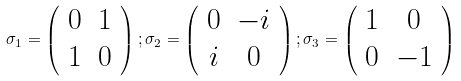Convert formula to latex. <formula><loc_0><loc_0><loc_500><loc_500>\sigma _ { 1 } = \left ( \begin{array} { c c } 0 & 1 \\ 1 & 0 \end{array} \right ) ; \sigma _ { 2 } = \left ( \begin{array} { c c } 0 & - i \\ i & 0 \end{array} \right ) ; \sigma _ { 3 } = \left ( \begin{array} { c c } 1 & 0 \\ 0 & - 1 \end{array} \right )</formula> 